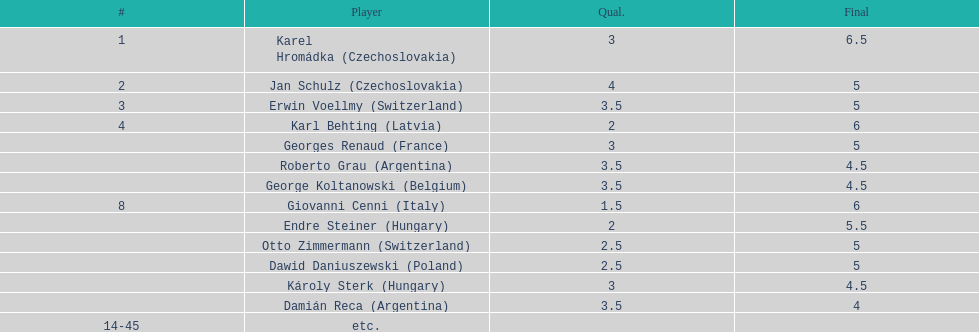How many players had final scores higher than 5? 4. 